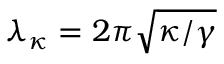<formula> <loc_0><loc_0><loc_500><loc_500>{ \lambda _ { \kappa } } = 2 \pi \sqrt { \kappa / \gamma }</formula> 